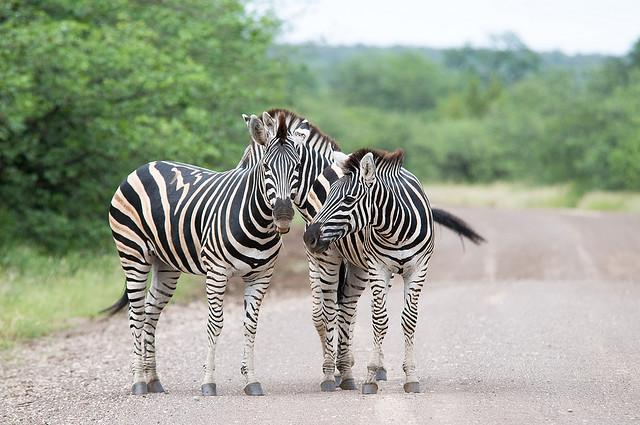What part of this photo would these animals never encounter in their natural habitat? Please explain your reasoning. pavement. Generally these animals wouldn't encounter anything man-made. 